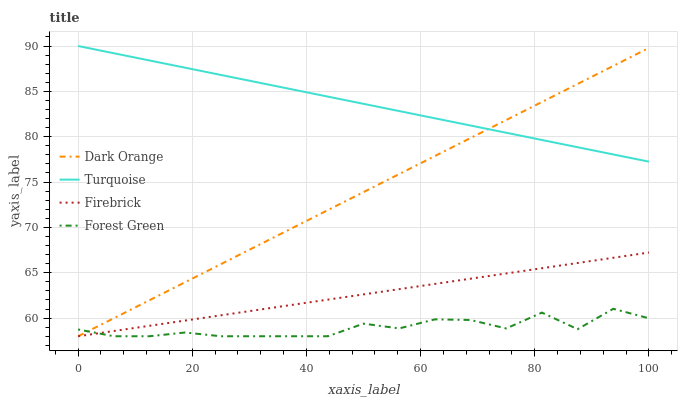Does Forest Green have the minimum area under the curve?
Answer yes or no. Yes. Does Turquoise have the maximum area under the curve?
Answer yes or no. Yes. Does Dark Orange have the minimum area under the curve?
Answer yes or no. No. Does Dark Orange have the maximum area under the curve?
Answer yes or no. No. Is Firebrick the smoothest?
Answer yes or no. Yes. Is Forest Green the roughest?
Answer yes or no. Yes. Is Dark Orange the smoothest?
Answer yes or no. No. Is Dark Orange the roughest?
Answer yes or no. No. Does Forest Green have the lowest value?
Answer yes or no. Yes. Does Turquoise have the lowest value?
Answer yes or no. No. Does Turquoise have the highest value?
Answer yes or no. Yes. Does Dark Orange have the highest value?
Answer yes or no. No. Is Firebrick less than Turquoise?
Answer yes or no. Yes. Is Turquoise greater than Forest Green?
Answer yes or no. Yes. Does Dark Orange intersect Turquoise?
Answer yes or no. Yes. Is Dark Orange less than Turquoise?
Answer yes or no. No. Is Dark Orange greater than Turquoise?
Answer yes or no. No. Does Firebrick intersect Turquoise?
Answer yes or no. No. 